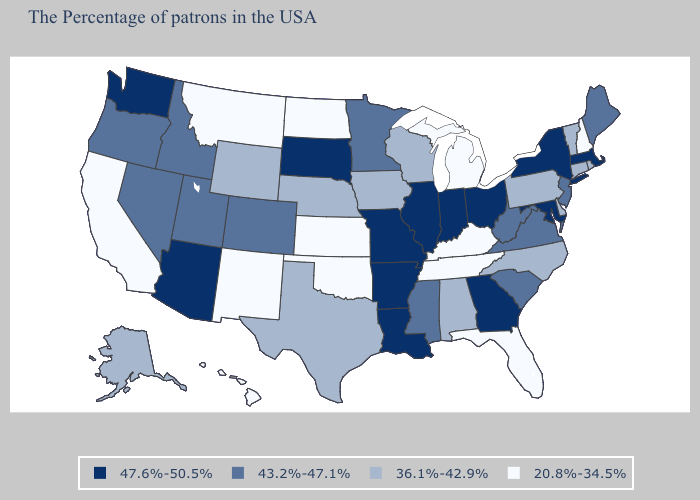What is the value of Utah?
Concise answer only. 43.2%-47.1%. Does Florida have the highest value in the South?
Write a very short answer. No. Is the legend a continuous bar?
Write a very short answer. No. What is the lowest value in the USA?
Concise answer only. 20.8%-34.5%. Among the states that border Arizona , does Nevada have the highest value?
Quick response, please. Yes. Does South Carolina have a lower value than North Dakota?
Keep it brief. No. Which states have the lowest value in the MidWest?
Short answer required. Michigan, Kansas, North Dakota. Which states hav the highest value in the MidWest?
Keep it brief. Ohio, Indiana, Illinois, Missouri, South Dakota. Among the states that border Connecticut , which have the highest value?
Be succinct. Massachusetts, New York. Does Rhode Island have the highest value in the USA?
Keep it brief. No. Which states have the lowest value in the West?
Write a very short answer. New Mexico, Montana, California, Hawaii. How many symbols are there in the legend?
Answer briefly. 4. What is the lowest value in the Northeast?
Quick response, please. 20.8%-34.5%. Name the states that have a value in the range 20.8%-34.5%?
Concise answer only. New Hampshire, Florida, Michigan, Kentucky, Tennessee, Kansas, Oklahoma, North Dakota, New Mexico, Montana, California, Hawaii. Which states have the lowest value in the West?
Be succinct. New Mexico, Montana, California, Hawaii. 